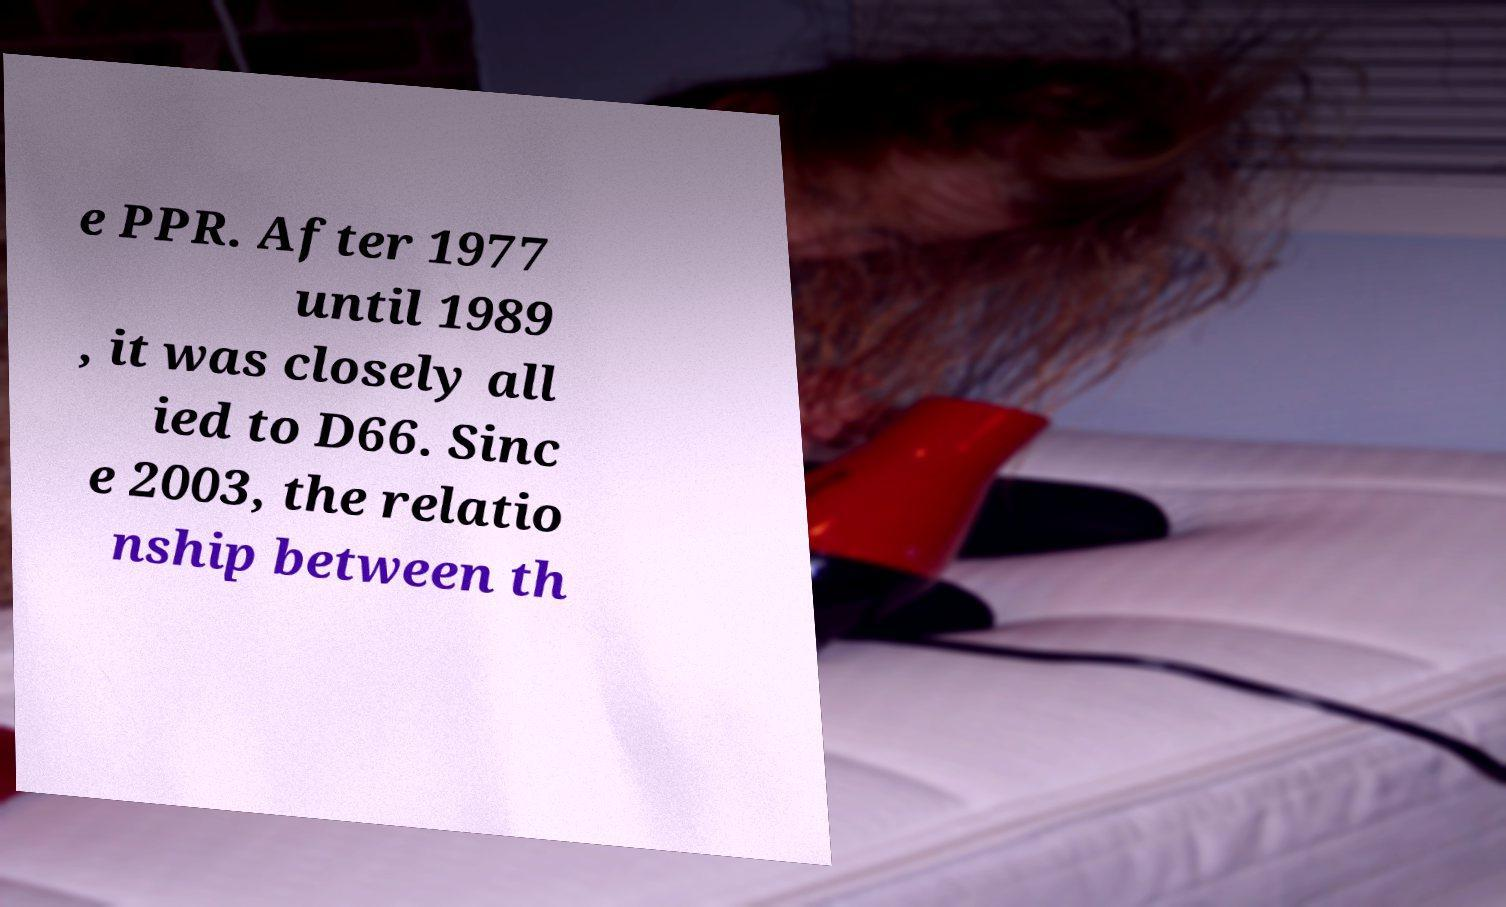There's text embedded in this image that I need extracted. Can you transcribe it verbatim? e PPR. After 1977 until 1989 , it was closely all ied to D66. Sinc e 2003, the relatio nship between th 